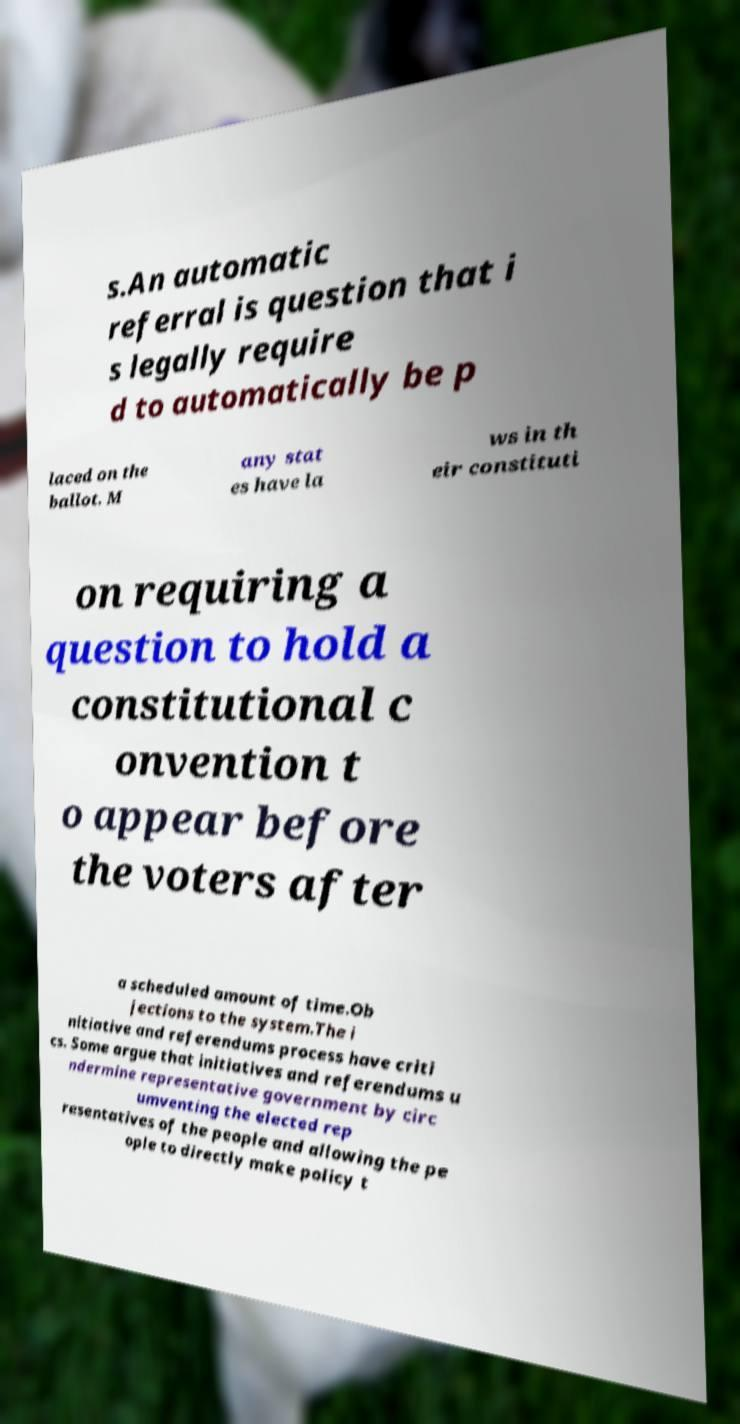Could you extract and type out the text from this image? s.An automatic referral is question that i s legally require d to automatically be p laced on the ballot. M any stat es have la ws in th eir constituti on requiring a question to hold a constitutional c onvention t o appear before the voters after a scheduled amount of time.Ob jections to the system.The i nitiative and referendums process have criti cs. Some argue that initiatives and referendums u ndermine representative government by circ umventing the elected rep resentatives of the people and allowing the pe ople to directly make policy t 